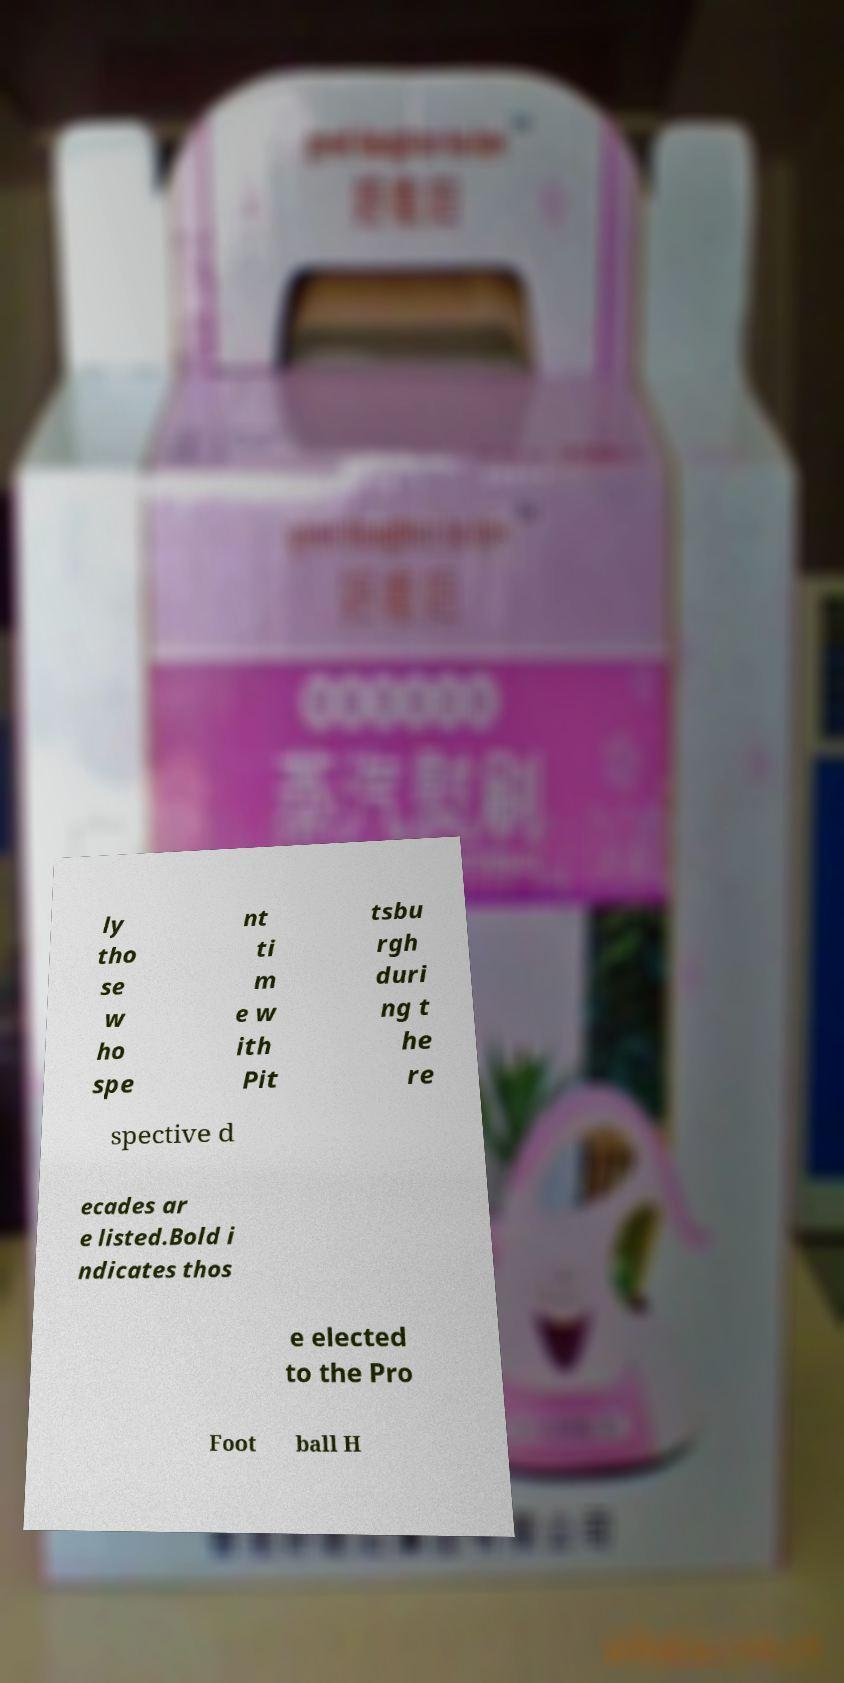Can you accurately transcribe the text from the provided image for me? ly tho se w ho spe nt ti m e w ith Pit tsbu rgh duri ng t he re spective d ecades ar e listed.Bold i ndicates thos e elected to the Pro Foot ball H 